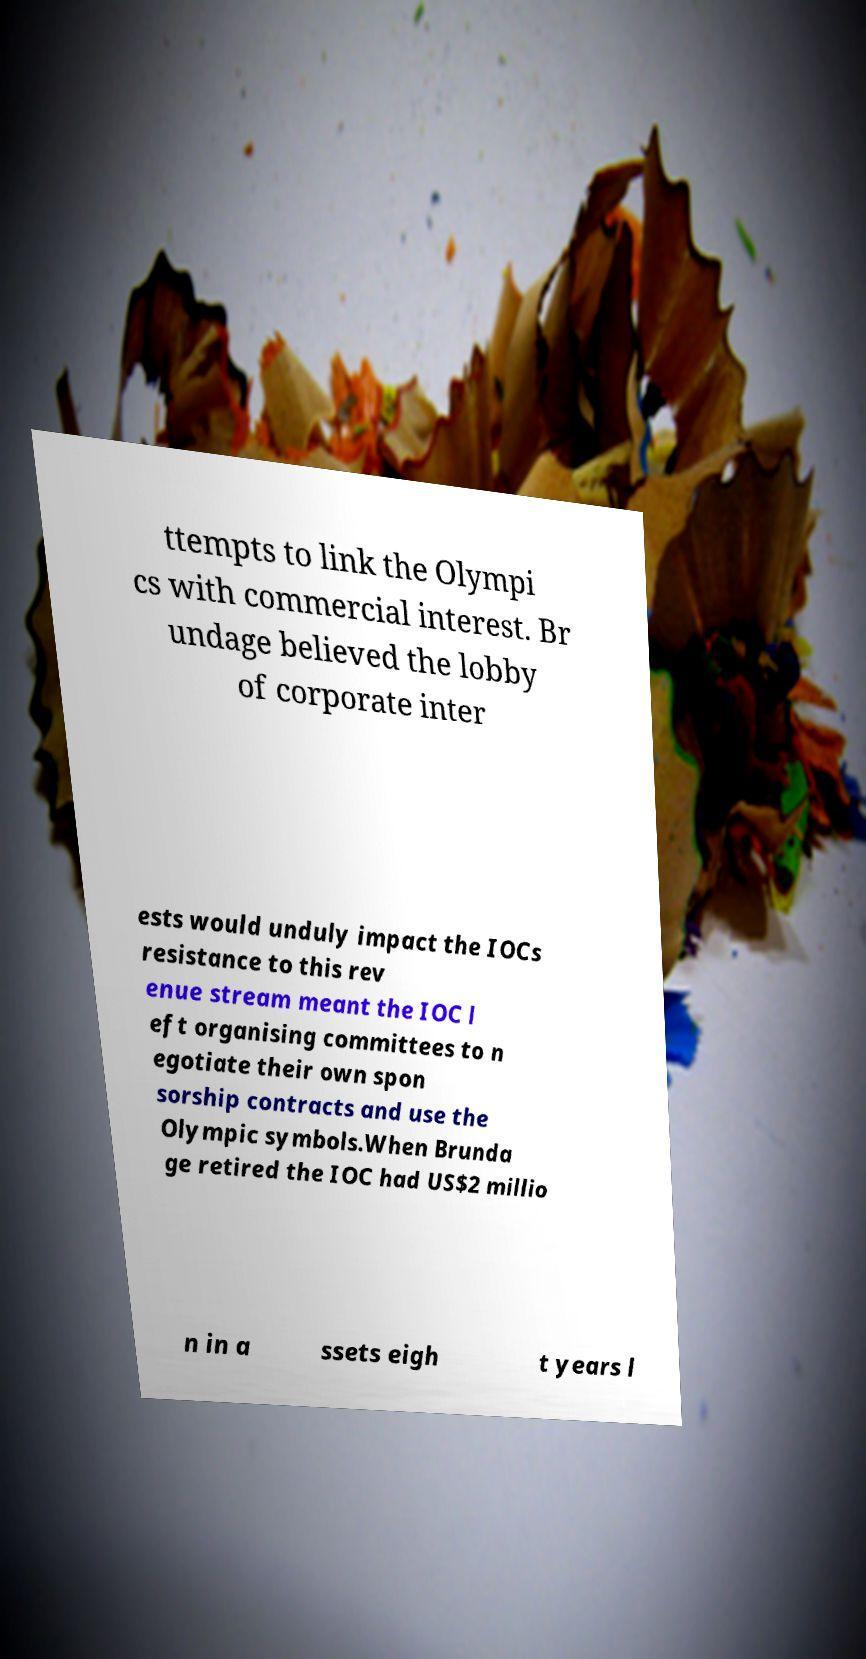Please read and relay the text visible in this image. What does it say? ttempts to link the Olympi cs with commercial interest. Br undage believed the lobby of corporate inter ests would unduly impact the IOCs resistance to this rev enue stream meant the IOC l eft organising committees to n egotiate their own spon sorship contracts and use the Olympic symbols.When Brunda ge retired the IOC had US$2 millio n in a ssets eigh t years l 